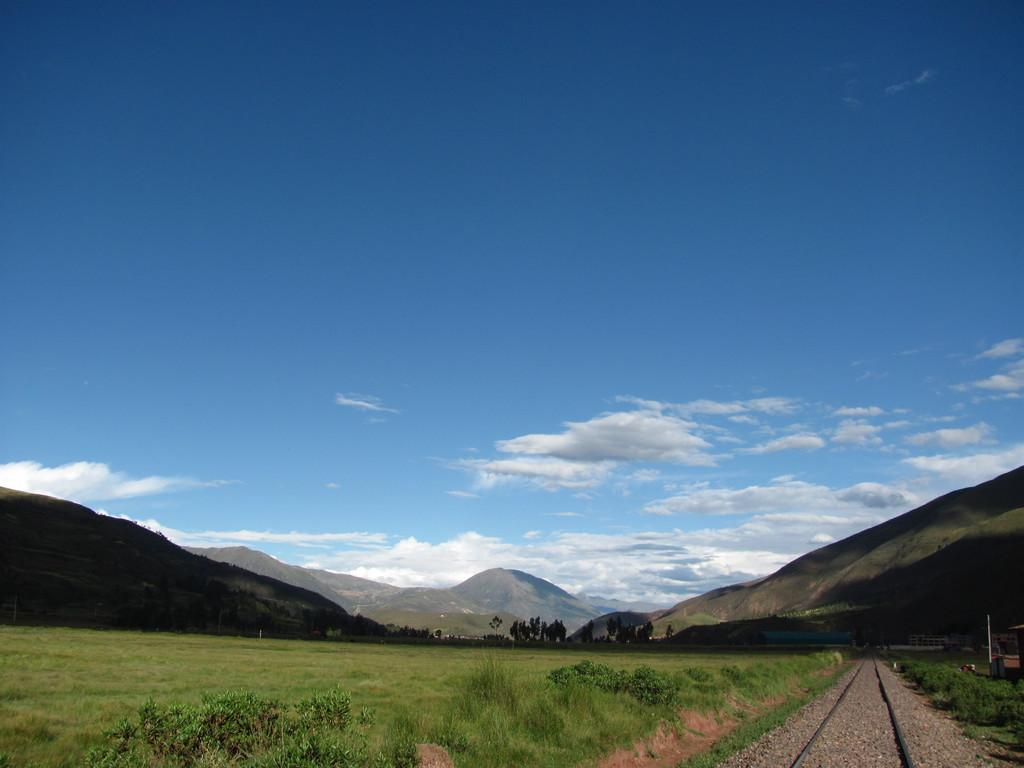What type of natural environment is visible at the bottom side of the image? There is greenery at the bottom side of the image. What part of the natural environment is visible at the top side of the image? There is sky at the top side of the image. What type of trade is happening in the image? There is no indication of trade in the image; it primarily features greenery and sky. Can you tell me how many mines are visible in the image? There are no mines present in the image. 